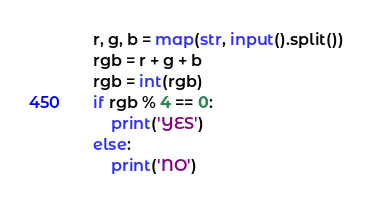Convert code to text. <code><loc_0><loc_0><loc_500><loc_500><_Python_>r, g, b = map(str, input().split())
rgb = r + g + b
rgb = int(rgb)
if rgb % 4 == 0:
	print('YES')
else:
	print('NO')</code> 